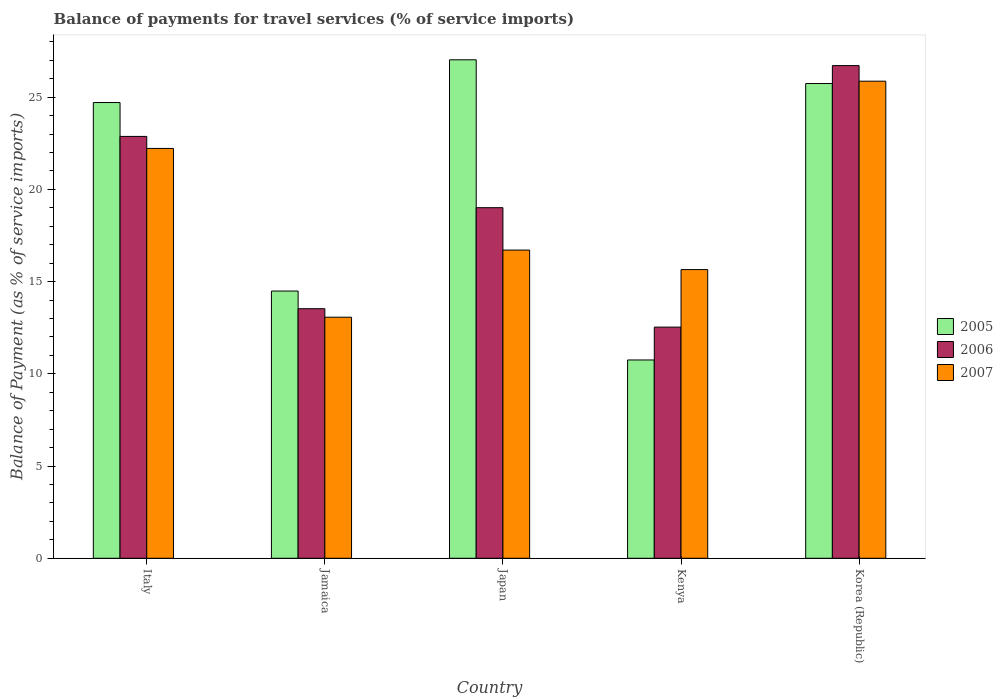How many groups of bars are there?
Your answer should be very brief. 5. What is the label of the 2nd group of bars from the left?
Offer a terse response. Jamaica. In how many cases, is the number of bars for a given country not equal to the number of legend labels?
Offer a very short reply. 0. What is the balance of payments for travel services in 2007 in Italy?
Provide a succinct answer. 22.22. Across all countries, what is the maximum balance of payments for travel services in 2006?
Offer a very short reply. 26.71. Across all countries, what is the minimum balance of payments for travel services in 2005?
Your answer should be compact. 10.75. In which country was the balance of payments for travel services in 2005 minimum?
Your answer should be compact. Kenya. What is the total balance of payments for travel services in 2007 in the graph?
Your answer should be compact. 93.51. What is the difference between the balance of payments for travel services in 2006 in Jamaica and that in Japan?
Ensure brevity in your answer.  -5.48. What is the difference between the balance of payments for travel services in 2006 in Jamaica and the balance of payments for travel services in 2007 in Japan?
Your response must be concise. -3.18. What is the average balance of payments for travel services in 2005 per country?
Provide a succinct answer. 20.54. What is the difference between the balance of payments for travel services of/in 2005 and balance of payments for travel services of/in 2006 in Japan?
Ensure brevity in your answer.  8.02. What is the ratio of the balance of payments for travel services in 2006 in Italy to that in Korea (Republic)?
Make the answer very short. 0.86. Is the difference between the balance of payments for travel services in 2005 in Japan and Korea (Republic) greater than the difference between the balance of payments for travel services in 2006 in Japan and Korea (Republic)?
Provide a succinct answer. Yes. What is the difference between the highest and the second highest balance of payments for travel services in 2006?
Provide a short and direct response. 7.7. What is the difference between the highest and the lowest balance of payments for travel services in 2007?
Provide a short and direct response. 12.79. In how many countries, is the balance of payments for travel services in 2006 greater than the average balance of payments for travel services in 2006 taken over all countries?
Your answer should be very brief. 3. What does the 3rd bar from the left in Korea (Republic) represents?
Give a very brief answer. 2007. What does the 2nd bar from the right in Kenya represents?
Ensure brevity in your answer.  2006. How many bars are there?
Your answer should be compact. 15. Are all the bars in the graph horizontal?
Offer a terse response. No. What is the difference between two consecutive major ticks on the Y-axis?
Give a very brief answer. 5. Are the values on the major ticks of Y-axis written in scientific E-notation?
Make the answer very short. No. Does the graph contain grids?
Ensure brevity in your answer.  No. What is the title of the graph?
Provide a succinct answer. Balance of payments for travel services (% of service imports). Does "1983" appear as one of the legend labels in the graph?
Give a very brief answer. No. What is the label or title of the X-axis?
Offer a terse response. Country. What is the label or title of the Y-axis?
Provide a short and direct response. Balance of Payment (as % of service imports). What is the Balance of Payment (as % of service imports) of 2005 in Italy?
Your answer should be compact. 24.71. What is the Balance of Payment (as % of service imports) in 2006 in Italy?
Ensure brevity in your answer.  22.87. What is the Balance of Payment (as % of service imports) in 2007 in Italy?
Give a very brief answer. 22.22. What is the Balance of Payment (as % of service imports) of 2005 in Jamaica?
Your answer should be compact. 14.49. What is the Balance of Payment (as % of service imports) of 2006 in Jamaica?
Your answer should be compact. 13.53. What is the Balance of Payment (as % of service imports) in 2007 in Jamaica?
Offer a very short reply. 13.07. What is the Balance of Payment (as % of service imports) of 2005 in Japan?
Your answer should be compact. 27.02. What is the Balance of Payment (as % of service imports) of 2006 in Japan?
Offer a terse response. 19.01. What is the Balance of Payment (as % of service imports) of 2007 in Japan?
Give a very brief answer. 16.71. What is the Balance of Payment (as % of service imports) in 2005 in Kenya?
Give a very brief answer. 10.75. What is the Balance of Payment (as % of service imports) of 2006 in Kenya?
Offer a very short reply. 12.53. What is the Balance of Payment (as % of service imports) of 2007 in Kenya?
Ensure brevity in your answer.  15.65. What is the Balance of Payment (as % of service imports) of 2005 in Korea (Republic)?
Ensure brevity in your answer.  25.74. What is the Balance of Payment (as % of service imports) in 2006 in Korea (Republic)?
Your answer should be compact. 26.71. What is the Balance of Payment (as % of service imports) of 2007 in Korea (Republic)?
Provide a short and direct response. 25.86. Across all countries, what is the maximum Balance of Payment (as % of service imports) of 2005?
Your response must be concise. 27.02. Across all countries, what is the maximum Balance of Payment (as % of service imports) of 2006?
Provide a short and direct response. 26.71. Across all countries, what is the maximum Balance of Payment (as % of service imports) in 2007?
Offer a terse response. 25.86. Across all countries, what is the minimum Balance of Payment (as % of service imports) in 2005?
Make the answer very short. 10.75. Across all countries, what is the minimum Balance of Payment (as % of service imports) in 2006?
Keep it short and to the point. 12.53. Across all countries, what is the minimum Balance of Payment (as % of service imports) of 2007?
Keep it short and to the point. 13.07. What is the total Balance of Payment (as % of service imports) in 2005 in the graph?
Keep it short and to the point. 102.7. What is the total Balance of Payment (as % of service imports) of 2006 in the graph?
Make the answer very short. 94.64. What is the total Balance of Payment (as % of service imports) in 2007 in the graph?
Keep it short and to the point. 93.51. What is the difference between the Balance of Payment (as % of service imports) of 2005 in Italy and that in Jamaica?
Your response must be concise. 10.22. What is the difference between the Balance of Payment (as % of service imports) of 2006 in Italy and that in Jamaica?
Your answer should be compact. 9.34. What is the difference between the Balance of Payment (as % of service imports) of 2007 in Italy and that in Jamaica?
Offer a very short reply. 9.15. What is the difference between the Balance of Payment (as % of service imports) of 2005 in Italy and that in Japan?
Provide a succinct answer. -2.32. What is the difference between the Balance of Payment (as % of service imports) in 2006 in Italy and that in Japan?
Ensure brevity in your answer.  3.86. What is the difference between the Balance of Payment (as % of service imports) in 2007 in Italy and that in Japan?
Make the answer very short. 5.51. What is the difference between the Balance of Payment (as % of service imports) of 2005 in Italy and that in Kenya?
Your response must be concise. 13.96. What is the difference between the Balance of Payment (as % of service imports) of 2006 in Italy and that in Kenya?
Ensure brevity in your answer.  10.34. What is the difference between the Balance of Payment (as % of service imports) in 2007 in Italy and that in Kenya?
Keep it short and to the point. 6.57. What is the difference between the Balance of Payment (as % of service imports) of 2005 in Italy and that in Korea (Republic)?
Your answer should be very brief. -1.03. What is the difference between the Balance of Payment (as % of service imports) in 2006 in Italy and that in Korea (Republic)?
Your response must be concise. -3.84. What is the difference between the Balance of Payment (as % of service imports) in 2007 in Italy and that in Korea (Republic)?
Offer a very short reply. -3.64. What is the difference between the Balance of Payment (as % of service imports) of 2005 in Jamaica and that in Japan?
Ensure brevity in your answer.  -12.54. What is the difference between the Balance of Payment (as % of service imports) in 2006 in Jamaica and that in Japan?
Keep it short and to the point. -5.48. What is the difference between the Balance of Payment (as % of service imports) of 2007 in Jamaica and that in Japan?
Keep it short and to the point. -3.64. What is the difference between the Balance of Payment (as % of service imports) of 2005 in Jamaica and that in Kenya?
Keep it short and to the point. 3.74. What is the difference between the Balance of Payment (as % of service imports) of 2006 in Jamaica and that in Kenya?
Offer a terse response. 1. What is the difference between the Balance of Payment (as % of service imports) of 2007 in Jamaica and that in Kenya?
Offer a very short reply. -2.58. What is the difference between the Balance of Payment (as % of service imports) of 2005 in Jamaica and that in Korea (Republic)?
Your answer should be very brief. -11.25. What is the difference between the Balance of Payment (as % of service imports) of 2006 in Jamaica and that in Korea (Republic)?
Ensure brevity in your answer.  -13.18. What is the difference between the Balance of Payment (as % of service imports) in 2007 in Jamaica and that in Korea (Republic)?
Provide a short and direct response. -12.79. What is the difference between the Balance of Payment (as % of service imports) in 2005 in Japan and that in Kenya?
Your answer should be compact. 16.27. What is the difference between the Balance of Payment (as % of service imports) of 2006 in Japan and that in Kenya?
Provide a short and direct response. 6.47. What is the difference between the Balance of Payment (as % of service imports) of 2007 in Japan and that in Kenya?
Your answer should be compact. 1.06. What is the difference between the Balance of Payment (as % of service imports) of 2005 in Japan and that in Korea (Republic)?
Provide a succinct answer. 1.29. What is the difference between the Balance of Payment (as % of service imports) in 2006 in Japan and that in Korea (Republic)?
Your answer should be compact. -7.7. What is the difference between the Balance of Payment (as % of service imports) in 2007 in Japan and that in Korea (Republic)?
Provide a short and direct response. -9.16. What is the difference between the Balance of Payment (as % of service imports) of 2005 in Kenya and that in Korea (Republic)?
Your response must be concise. -14.99. What is the difference between the Balance of Payment (as % of service imports) of 2006 in Kenya and that in Korea (Republic)?
Your answer should be very brief. -14.18. What is the difference between the Balance of Payment (as % of service imports) of 2007 in Kenya and that in Korea (Republic)?
Your answer should be very brief. -10.21. What is the difference between the Balance of Payment (as % of service imports) of 2005 in Italy and the Balance of Payment (as % of service imports) of 2006 in Jamaica?
Provide a short and direct response. 11.18. What is the difference between the Balance of Payment (as % of service imports) in 2005 in Italy and the Balance of Payment (as % of service imports) in 2007 in Jamaica?
Keep it short and to the point. 11.64. What is the difference between the Balance of Payment (as % of service imports) in 2006 in Italy and the Balance of Payment (as % of service imports) in 2007 in Jamaica?
Your answer should be very brief. 9.8. What is the difference between the Balance of Payment (as % of service imports) of 2005 in Italy and the Balance of Payment (as % of service imports) of 2006 in Japan?
Give a very brief answer. 5.7. What is the difference between the Balance of Payment (as % of service imports) of 2005 in Italy and the Balance of Payment (as % of service imports) of 2007 in Japan?
Provide a short and direct response. 8. What is the difference between the Balance of Payment (as % of service imports) of 2006 in Italy and the Balance of Payment (as % of service imports) of 2007 in Japan?
Ensure brevity in your answer.  6.16. What is the difference between the Balance of Payment (as % of service imports) in 2005 in Italy and the Balance of Payment (as % of service imports) in 2006 in Kenya?
Provide a short and direct response. 12.17. What is the difference between the Balance of Payment (as % of service imports) of 2005 in Italy and the Balance of Payment (as % of service imports) of 2007 in Kenya?
Give a very brief answer. 9.06. What is the difference between the Balance of Payment (as % of service imports) in 2006 in Italy and the Balance of Payment (as % of service imports) in 2007 in Kenya?
Your answer should be compact. 7.22. What is the difference between the Balance of Payment (as % of service imports) of 2005 in Italy and the Balance of Payment (as % of service imports) of 2006 in Korea (Republic)?
Your answer should be compact. -2. What is the difference between the Balance of Payment (as % of service imports) of 2005 in Italy and the Balance of Payment (as % of service imports) of 2007 in Korea (Republic)?
Give a very brief answer. -1.16. What is the difference between the Balance of Payment (as % of service imports) of 2006 in Italy and the Balance of Payment (as % of service imports) of 2007 in Korea (Republic)?
Keep it short and to the point. -2.99. What is the difference between the Balance of Payment (as % of service imports) in 2005 in Jamaica and the Balance of Payment (as % of service imports) in 2006 in Japan?
Give a very brief answer. -4.52. What is the difference between the Balance of Payment (as % of service imports) of 2005 in Jamaica and the Balance of Payment (as % of service imports) of 2007 in Japan?
Your answer should be very brief. -2.22. What is the difference between the Balance of Payment (as % of service imports) in 2006 in Jamaica and the Balance of Payment (as % of service imports) in 2007 in Japan?
Your response must be concise. -3.18. What is the difference between the Balance of Payment (as % of service imports) in 2005 in Jamaica and the Balance of Payment (as % of service imports) in 2006 in Kenya?
Your answer should be very brief. 1.96. What is the difference between the Balance of Payment (as % of service imports) of 2005 in Jamaica and the Balance of Payment (as % of service imports) of 2007 in Kenya?
Provide a short and direct response. -1.16. What is the difference between the Balance of Payment (as % of service imports) in 2006 in Jamaica and the Balance of Payment (as % of service imports) in 2007 in Kenya?
Your response must be concise. -2.12. What is the difference between the Balance of Payment (as % of service imports) of 2005 in Jamaica and the Balance of Payment (as % of service imports) of 2006 in Korea (Republic)?
Your answer should be compact. -12.22. What is the difference between the Balance of Payment (as % of service imports) of 2005 in Jamaica and the Balance of Payment (as % of service imports) of 2007 in Korea (Republic)?
Provide a short and direct response. -11.38. What is the difference between the Balance of Payment (as % of service imports) of 2006 in Jamaica and the Balance of Payment (as % of service imports) of 2007 in Korea (Republic)?
Your answer should be compact. -12.33. What is the difference between the Balance of Payment (as % of service imports) of 2005 in Japan and the Balance of Payment (as % of service imports) of 2006 in Kenya?
Give a very brief answer. 14.49. What is the difference between the Balance of Payment (as % of service imports) of 2005 in Japan and the Balance of Payment (as % of service imports) of 2007 in Kenya?
Provide a short and direct response. 11.37. What is the difference between the Balance of Payment (as % of service imports) in 2006 in Japan and the Balance of Payment (as % of service imports) in 2007 in Kenya?
Offer a very short reply. 3.36. What is the difference between the Balance of Payment (as % of service imports) of 2005 in Japan and the Balance of Payment (as % of service imports) of 2006 in Korea (Republic)?
Offer a terse response. 0.32. What is the difference between the Balance of Payment (as % of service imports) in 2005 in Japan and the Balance of Payment (as % of service imports) in 2007 in Korea (Republic)?
Your response must be concise. 1.16. What is the difference between the Balance of Payment (as % of service imports) in 2006 in Japan and the Balance of Payment (as % of service imports) in 2007 in Korea (Republic)?
Your answer should be very brief. -6.86. What is the difference between the Balance of Payment (as % of service imports) in 2005 in Kenya and the Balance of Payment (as % of service imports) in 2006 in Korea (Republic)?
Make the answer very short. -15.96. What is the difference between the Balance of Payment (as % of service imports) of 2005 in Kenya and the Balance of Payment (as % of service imports) of 2007 in Korea (Republic)?
Give a very brief answer. -15.11. What is the difference between the Balance of Payment (as % of service imports) in 2006 in Kenya and the Balance of Payment (as % of service imports) in 2007 in Korea (Republic)?
Offer a terse response. -13.33. What is the average Balance of Payment (as % of service imports) of 2005 per country?
Provide a short and direct response. 20.54. What is the average Balance of Payment (as % of service imports) of 2006 per country?
Keep it short and to the point. 18.93. What is the average Balance of Payment (as % of service imports) of 2007 per country?
Your response must be concise. 18.7. What is the difference between the Balance of Payment (as % of service imports) of 2005 and Balance of Payment (as % of service imports) of 2006 in Italy?
Give a very brief answer. 1.84. What is the difference between the Balance of Payment (as % of service imports) in 2005 and Balance of Payment (as % of service imports) in 2007 in Italy?
Give a very brief answer. 2.49. What is the difference between the Balance of Payment (as % of service imports) of 2006 and Balance of Payment (as % of service imports) of 2007 in Italy?
Keep it short and to the point. 0.65. What is the difference between the Balance of Payment (as % of service imports) in 2005 and Balance of Payment (as % of service imports) in 2006 in Jamaica?
Your answer should be compact. 0.96. What is the difference between the Balance of Payment (as % of service imports) of 2005 and Balance of Payment (as % of service imports) of 2007 in Jamaica?
Offer a terse response. 1.42. What is the difference between the Balance of Payment (as % of service imports) in 2006 and Balance of Payment (as % of service imports) in 2007 in Jamaica?
Your response must be concise. 0.46. What is the difference between the Balance of Payment (as % of service imports) in 2005 and Balance of Payment (as % of service imports) in 2006 in Japan?
Your response must be concise. 8.02. What is the difference between the Balance of Payment (as % of service imports) in 2005 and Balance of Payment (as % of service imports) in 2007 in Japan?
Give a very brief answer. 10.31. What is the difference between the Balance of Payment (as % of service imports) of 2006 and Balance of Payment (as % of service imports) of 2007 in Japan?
Your response must be concise. 2.3. What is the difference between the Balance of Payment (as % of service imports) of 2005 and Balance of Payment (as % of service imports) of 2006 in Kenya?
Your response must be concise. -1.78. What is the difference between the Balance of Payment (as % of service imports) of 2005 and Balance of Payment (as % of service imports) of 2007 in Kenya?
Offer a terse response. -4.9. What is the difference between the Balance of Payment (as % of service imports) in 2006 and Balance of Payment (as % of service imports) in 2007 in Kenya?
Make the answer very short. -3.12. What is the difference between the Balance of Payment (as % of service imports) in 2005 and Balance of Payment (as % of service imports) in 2006 in Korea (Republic)?
Your answer should be very brief. -0.97. What is the difference between the Balance of Payment (as % of service imports) in 2005 and Balance of Payment (as % of service imports) in 2007 in Korea (Republic)?
Your response must be concise. -0.13. What is the difference between the Balance of Payment (as % of service imports) in 2006 and Balance of Payment (as % of service imports) in 2007 in Korea (Republic)?
Offer a terse response. 0.84. What is the ratio of the Balance of Payment (as % of service imports) in 2005 in Italy to that in Jamaica?
Give a very brief answer. 1.71. What is the ratio of the Balance of Payment (as % of service imports) in 2006 in Italy to that in Jamaica?
Your answer should be very brief. 1.69. What is the ratio of the Balance of Payment (as % of service imports) of 2007 in Italy to that in Jamaica?
Make the answer very short. 1.7. What is the ratio of the Balance of Payment (as % of service imports) of 2005 in Italy to that in Japan?
Offer a very short reply. 0.91. What is the ratio of the Balance of Payment (as % of service imports) of 2006 in Italy to that in Japan?
Offer a very short reply. 1.2. What is the ratio of the Balance of Payment (as % of service imports) of 2007 in Italy to that in Japan?
Your answer should be very brief. 1.33. What is the ratio of the Balance of Payment (as % of service imports) of 2005 in Italy to that in Kenya?
Provide a succinct answer. 2.3. What is the ratio of the Balance of Payment (as % of service imports) in 2006 in Italy to that in Kenya?
Your answer should be very brief. 1.82. What is the ratio of the Balance of Payment (as % of service imports) in 2007 in Italy to that in Kenya?
Give a very brief answer. 1.42. What is the ratio of the Balance of Payment (as % of service imports) of 2005 in Italy to that in Korea (Republic)?
Ensure brevity in your answer.  0.96. What is the ratio of the Balance of Payment (as % of service imports) in 2006 in Italy to that in Korea (Republic)?
Offer a very short reply. 0.86. What is the ratio of the Balance of Payment (as % of service imports) in 2007 in Italy to that in Korea (Republic)?
Your answer should be very brief. 0.86. What is the ratio of the Balance of Payment (as % of service imports) in 2005 in Jamaica to that in Japan?
Offer a terse response. 0.54. What is the ratio of the Balance of Payment (as % of service imports) of 2006 in Jamaica to that in Japan?
Offer a terse response. 0.71. What is the ratio of the Balance of Payment (as % of service imports) of 2007 in Jamaica to that in Japan?
Your answer should be compact. 0.78. What is the ratio of the Balance of Payment (as % of service imports) of 2005 in Jamaica to that in Kenya?
Keep it short and to the point. 1.35. What is the ratio of the Balance of Payment (as % of service imports) in 2006 in Jamaica to that in Kenya?
Offer a very short reply. 1.08. What is the ratio of the Balance of Payment (as % of service imports) in 2007 in Jamaica to that in Kenya?
Provide a succinct answer. 0.83. What is the ratio of the Balance of Payment (as % of service imports) in 2005 in Jamaica to that in Korea (Republic)?
Make the answer very short. 0.56. What is the ratio of the Balance of Payment (as % of service imports) in 2006 in Jamaica to that in Korea (Republic)?
Make the answer very short. 0.51. What is the ratio of the Balance of Payment (as % of service imports) in 2007 in Jamaica to that in Korea (Republic)?
Keep it short and to the point. 0.51. What is the ratio of the Balance of Payment (as % of service imports) of 2005 in Japan to that in Kenya?
Keep it short and to the point. 2.51. What is the ratio of the Balance of Payment (as % of service imports) of 2006 in Japan to that in Kenya?
Keep it short and to the point. 1.52. What is the ratio of the Balance of Payment (as % of service imports) in 2007 in Japan to that in Kenya?
Your answer should be compact. 1.07. What is the ratio of the Balance of Payment (as % of service imports) of 2005 in Japan to that in Korea (Republic)?
Ensure brevity in your answer.  1.05. What is the ratio of the Balance of Payment (as % of service imports) in 2006 in Japan to that in Korea (Republic)?
Offer a very short reply. 0.71. What is the ratio of the Balance of Payment (as % of service imports) in 2007 in Japan to that in Korea (Republic)?
Ensure brevity in your answer.  0.65. What is the ratio of the Balance of Payment (as % of service imports) in 2005 in Kenya to that in Korea (Republic)?
Give a very brief answer. 0.42. What is the ratio of the Balance of Payment (as % of service imports) of 2006 in Kenya to that in Korea (Republic)?
Provide a succinct answer. 0.47. What is the ratio of the Balance of Payment (as % of service imports) in 2007 in Kenya to that in Korea (Republic)?
Your response must be concise. 0.61. What is the difference between the highest and the second highest Balance of Payment (as % of service imports) of 2005?
Your response must be concise. 1.29. What is the difference between the highest and the second highest Balance of Payment (as % of service imports) of 2006?
Ensure brevity in your answer.  3.84. What is the difference between the highest and the second highest Balance of Payment (as % of service imports) in 2007?
Your answer should be compact. 3.64. What is the difference between the highest and the lowest Balance of Payment (as % of service imports) in 2005?
Provide a succinct answer. 16.27. What is the difference between the highest and the lowest Balance of Payment (as % of service imports) of 2006?
Provide a succinct answer. 14.18. What is the difference between the highest and the lowest Balance of Payment (as % of service imports) of 2007?
Provide a short and direct response. 12.79. 